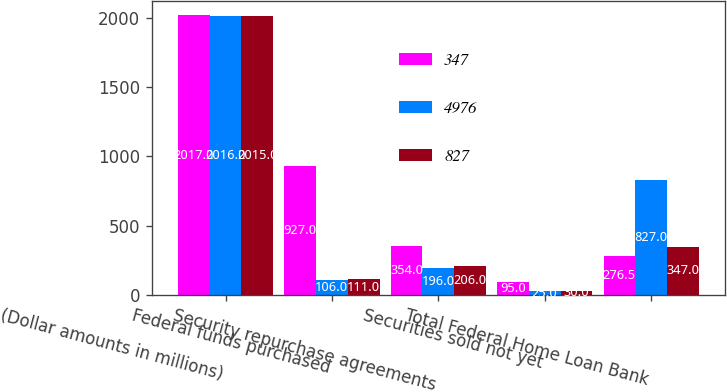<chart> <loc_0><loc_0><loc_500><loc_500><stacked_bar_chart><ecel><fcel>(Dollar amounts in millions)<fcel>Federal funds purchased<fcel>Security repurchase agreements<fcel>Securities sold not yet<fcel>Total Federal Home Loan Bank<nl><fcel>347<fcel>2017<fcel>927<fcel>354<fcel>95<fcel>276.5<nl><fcel>4976<fcel>2016<fcel>106<fcel>196<fcel>25<fcel>827<nl><fcel>827<fcel>2015<fcel>111<fcel>206<fcel>30<fcel>347<nl></chart> 